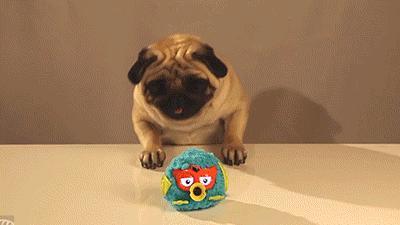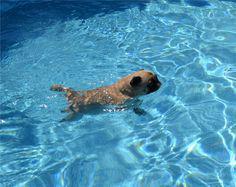The first image is the image on the left, the second image is the image on the right. For the images shown, is this caption "In both of the images there is a dog in a swimming pool." true? Answer yes or no. No. The first image is the image on the left, the second image is the image on the right. Assess this claim about the two images: "Only one of the images shows a dog in the water.". Correct or not? Answer yes or no. Yes. 